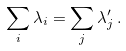<formula> <loc_0><loc_0><loc_500><loc_500>\sum _ { i } \lambda _ { i } = \sum _ { j } \lambda ^ { \prime } _ { j } \, .</formula> 